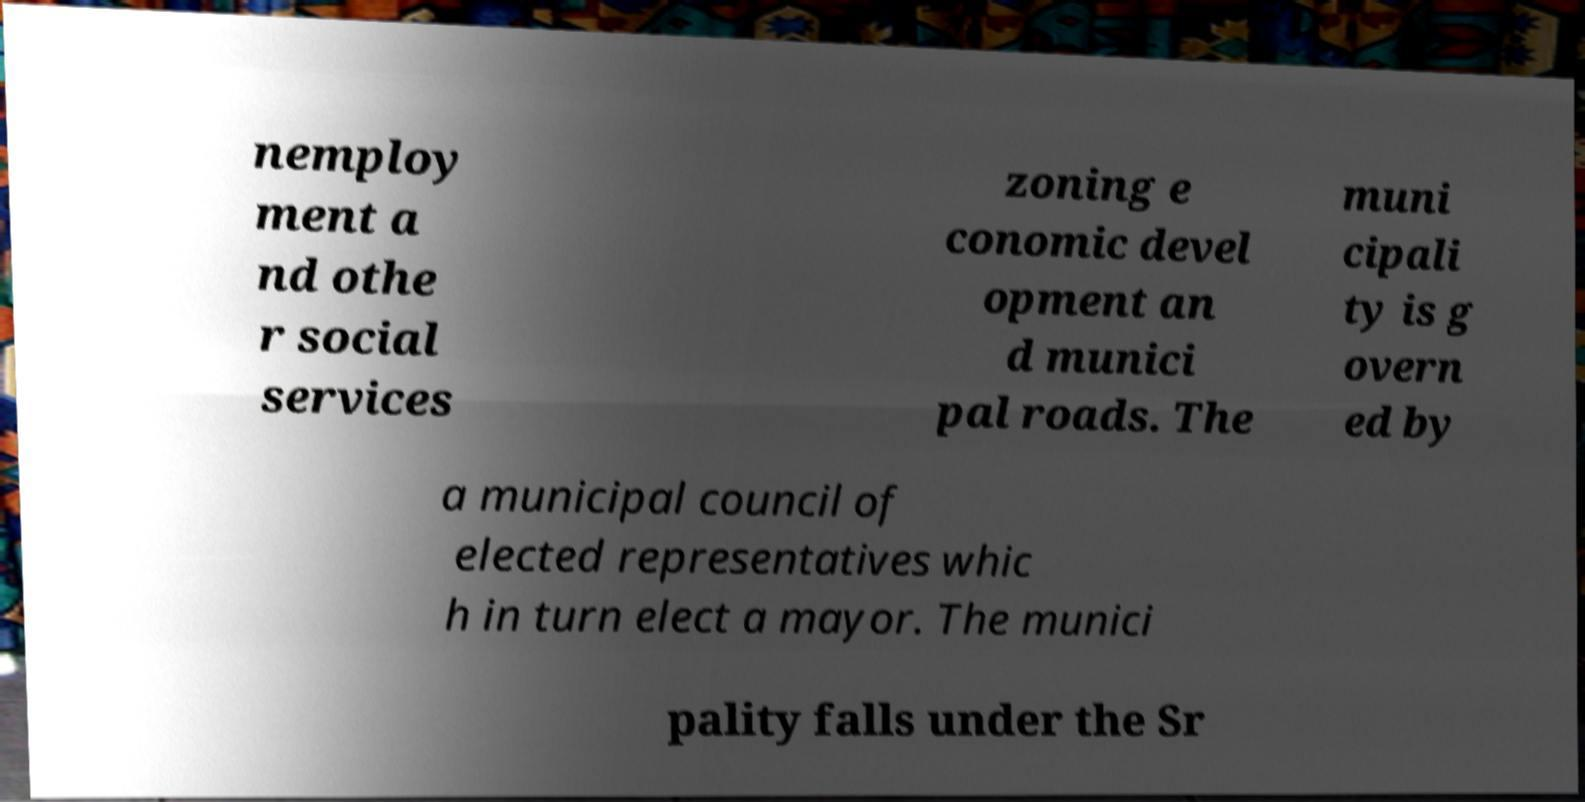Could you assist in decoding the text presented in this image and type it out clearly? nemploy ment a nd othe r social services zoning e conomic devel opment an d munici pal roads. The muni cipali ty is g overn ed by a municipal council of elected representatives whic h in turn elect a mayor. The munici pality falls under the Sr 